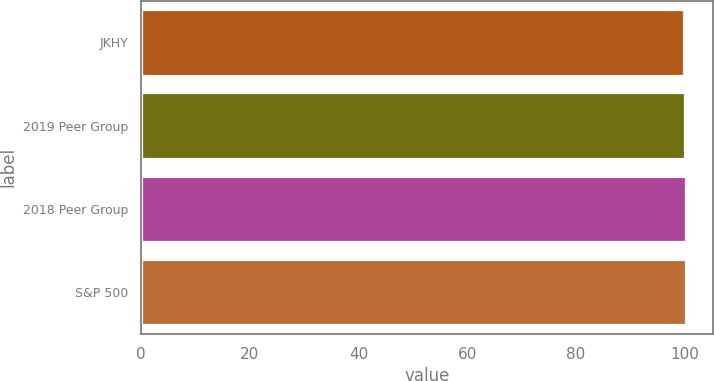Convert chart to OTSL. <chart><loc_0><loc_0><loc_500><loc_500><bar_chart><fcel>JKHY<fcel>2019 Peer Group<fcel>2018 Peer Group<fcel>S&P 500<nl><fcel>100<fcel>100.1<fcel>100.2<fcel>100.3<nl></chart> 